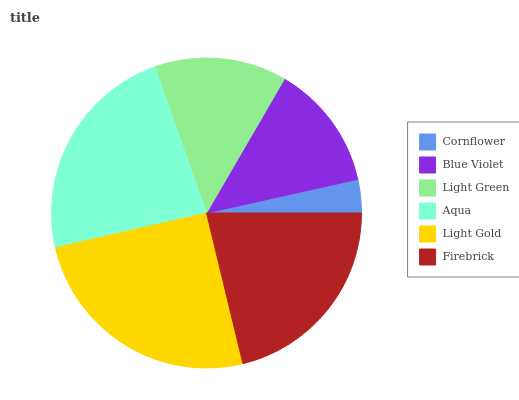Is Cornflower the minimum?
Answer yes or no. Yes. Is Light Gold the maximum?
Answer yes or no. Yes. Is Blue Violet the minimum?
Answer yes or no. No. Is Blue Violet the maximum?
Answer yes or no. No. Is Blue Violet greater than Cornflower?
Answer yes or no. Yes. Is Cornflower less than Blue Violet?
Answer yes or no. Yes. Is Cornflower greater than Blue Violet?
Answer yes or no. No. Is Blue Violet less than Cornflower?
Answer yes or no. No. Is Firebrick the high median?
Answer yes or no. Yes. Is Light Green the low median?
Answer yes or no. Yes. Is Light Green the high median?
Answer yes or no. No. Is Light Gold the low median?
Answer yes or no. No. 